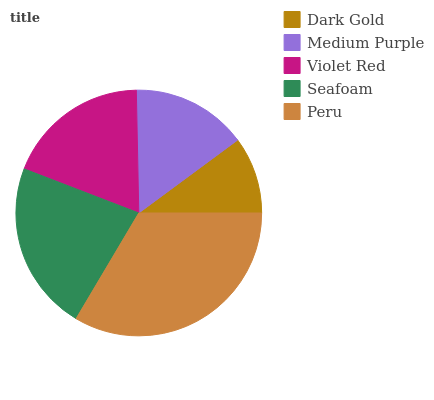Is Dark Gold the minimum?
Answer yes or no. Yes. Is Peru the maximum?
Answer yes or no. Yes. Is Medium Purple the minimum?
Answer yes or no. No. Is Medium Purple the maximum?
Answer yes or no. No. Is Medium Purple greater than Dark Gold?
Answer yes or no. Yes. Is Dark Gold less than Medium Purple?
Answer yes or no. Yes. Is Dark Gold greater than Medium Purple?
Answer yes or no. No. Is Medium Purple less than Dark Gold?
Answer yes or no. No. Is Violet Red the high median?
Answer yes or no. Yes. Is Violet Red the low median?
Answer yes or no. Yes. Is Dark Gold the high median?
Answer yes or no. No. Is Seafoam the low median?
Answer yes or no. No. 